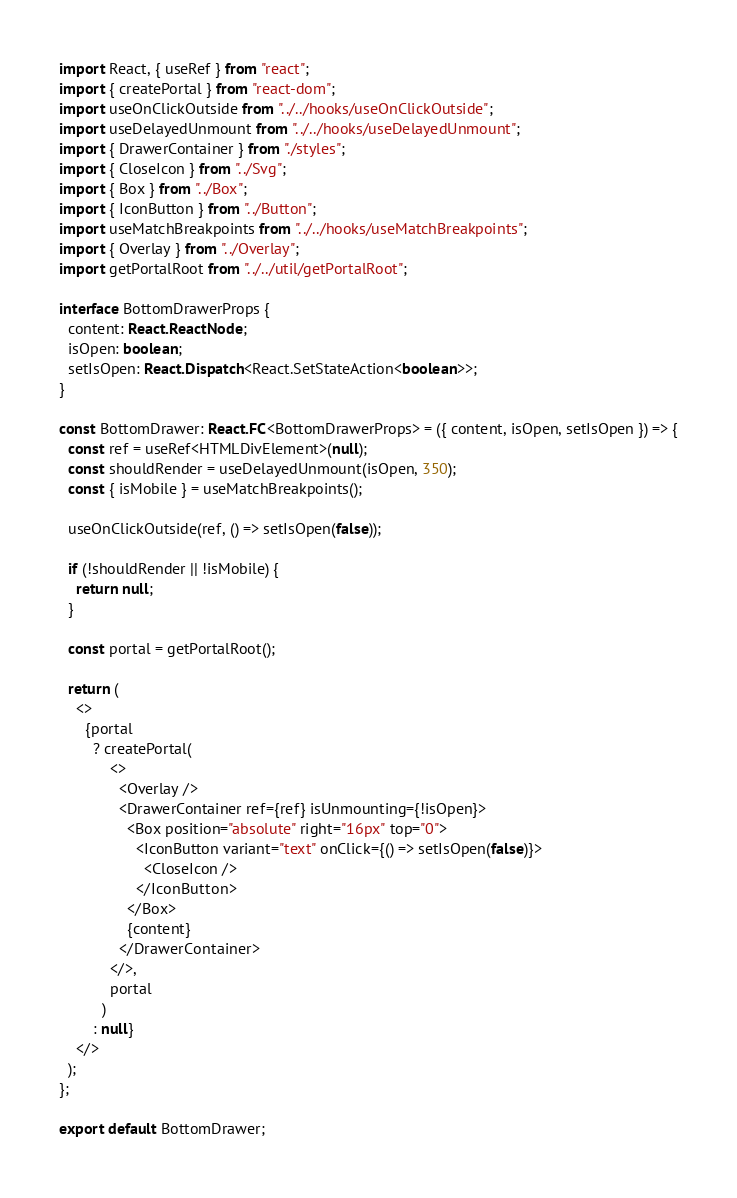<code> <loc_0><loc_0><loc_500><loc_500><_TypeScript_>import React, { useRef } from "react";
import { createPortal } from "react-dom";
import useOnClickOutside from "../../hooks/useOnClickOutside";
import useDelayedUnmount from "../../hooks/useDelayedUnmount";
import { DrawerContainer } from "./styles";
import { CloseIcon } from "../Svg";
import { Box } from "../Box";
import { IconButton } from "../Button";
import useMatchBreakpoints from "../../hooks/useMatchBreakpoints";
import { Overlay } from "../Overlay";
import getPortalRoot from "../../util/getPortalRoot";

interface BottomDrawerProps {
  content: React.ReactNode;
  isOpen: boolean;
  setIsOpen: React.Dispatch<React.SetStateAction<boolean>>;
}

const BottomDrawer: React.FC<BottomDrawerProps> = ({ content, isOpen, setIsOpen }) => {
  const ref = useRef<HTMLDivElement>(null);
  const shouldRender = useDelayedUnmount(isOpen, 350);
  const { isMobile } = useMatchBreakpoints();

  useOnClickOutside(ref, () => setIsOpen(false));

  if (!shouldRender || !isMobile) {
    return null;
  }

  const portal = getPortalRoot();

  return (
    <>
      {portal
        ? createPortal(
            <>
              <Overlay />
              <DrawerContainer ref={ref} isUnmounting={!isOpen}>
                <Box position="absolute" right="16px" top="0">
                  <IconButton variant="text" onClick={() => setIsOpen(false)}>
                    <CloseIcon />
                  </IconButton>
                </Box>
                {content}
              </DrawerContainer>
            </>,
            portal
          )
        : null}
    </>
  );
};

export default BottomDrawer;
</code> 